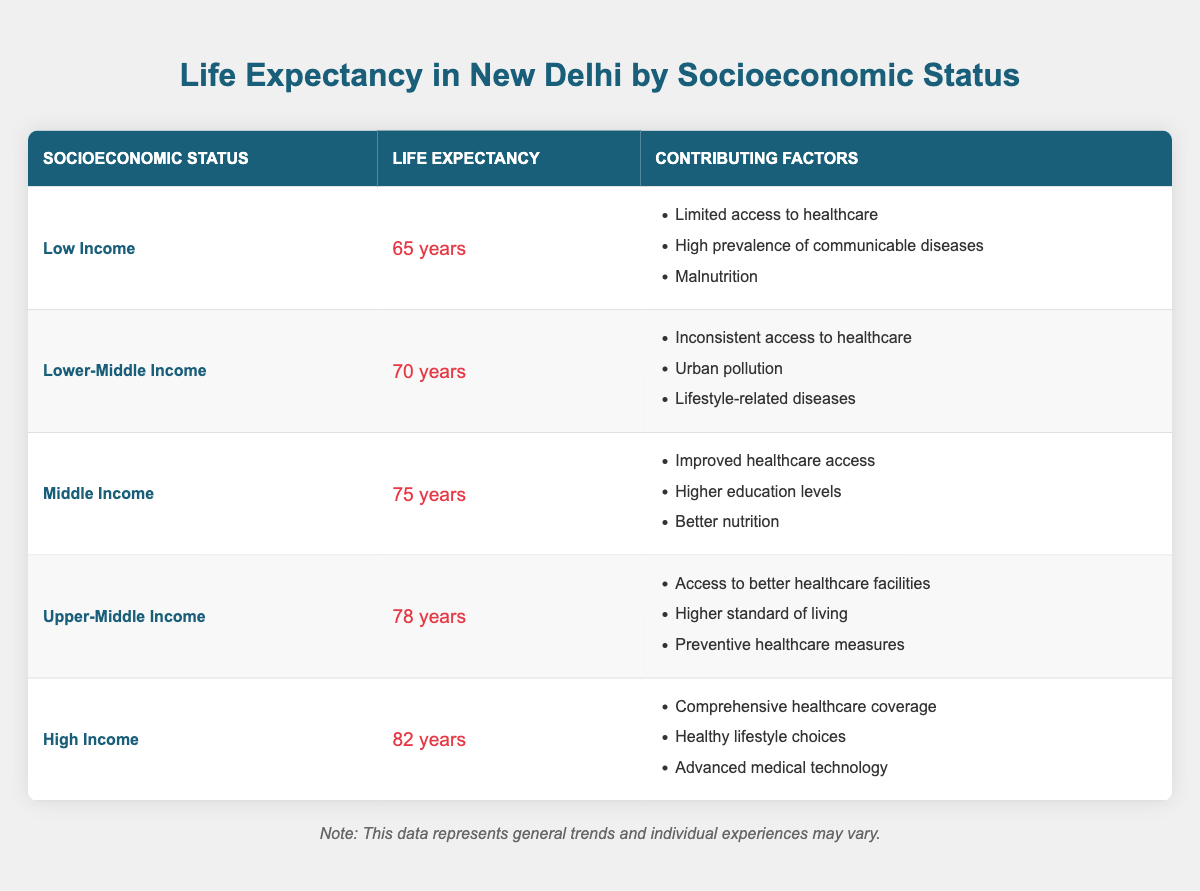What is the life expectancy for individuals in the High Income category? The table shows that the life expectancy for the High Income category is listed as 82 years.
Answer: 82 years Which socioeconomic status has the lowest life expectancy? By examining the table, the Low Income category is shown to have the lowest life expectancy at 65 years.
Answer: Low Income What factors contribute to life expectancy in the Upper-Middle Income category? The table notes three specific factors for the Upper-Middle Income category: access to better healthcare facilities, higher standard of living, and preventive healthcare measures.
Answer: Access to better healthcare facilities, higher standard of living, preventive healthcare measures What is the difference in life expectancy between the Middle Income and Upper-Middle Income categories? The life expectancy for Middle Income is 75 years and for Upper-Middle Income is 78 years. Therefore, the difference is 78 - 75 = 3 years.
Answer: 3 years True or False: Individuals in the Lower-Middle Income category face a higher risk of malnutrition than those in the High Income category. The table indicates that malnutrition is noted as a factor for the Low Income category, not for High Income, making the statement false.
Answer: False If you were to average the life expectancies of the Middle Income and Upper-Middle Income categories, what would it be? The life expectancy for Middle Income is 75 years and for Upper-Middle Income is 78 years. The average can be calculated as (75 + 78) / 2 = 76.5 years.
Answer: 76.5 years How many factors are listed for the Lower-Middle Income category, and what are they? The table lists three factors for the Lower-Middle Income category: inconsistent access to healthcare, urban pollution, and lifestyle-related diseases.
Answer: Three factors: inconsistent access to healthcare, urban pollution, lifestyle-related diseases Which socioeconomic status has the highest average life expectancy of the five categories listed? The High Income category has the highest life expectancy at 82 years, indicating it has the highest average among the listed categories.
Answer: High Income What trend can be observed regarding life expectancy as socioeconomic status increases? The table shows a clear trend that life expectancy increases with higher socioeconomic status, ranging from 65 years in Low Income to 82 years in High Income.
Answer: Life expectancy increases with higher socioeconomic status 